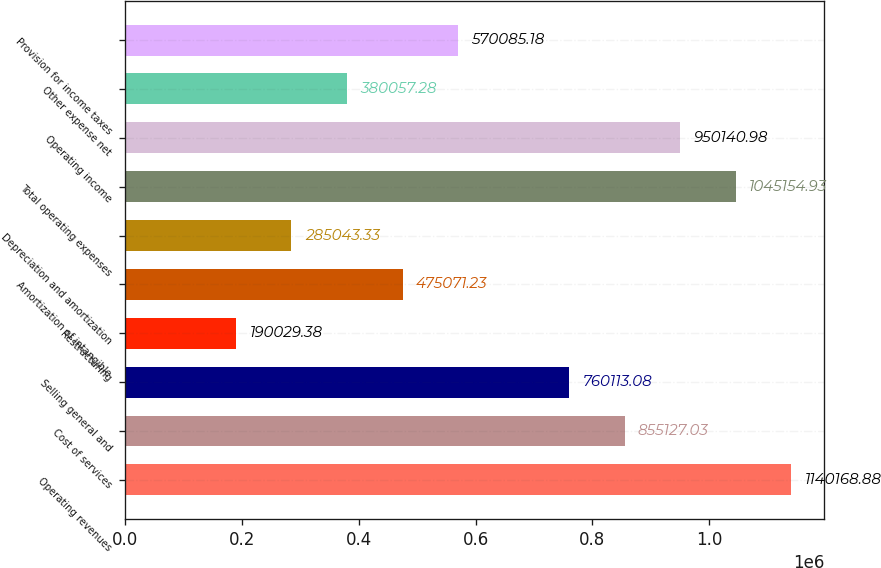Convert chart. <chart><loc_0><loc_0><loc_500><loc_500><bar_chart><fcel>Operating revenues<fcel>Cost of services<fcel>Selling general and<fcel>Restructuring<fcel>Amortization of intangible<fcel>Depreciation and amortization<fcel>Total operating expenses<fcel>Operating income<fcel>Other expense net<fcel>Provision for income taxes<nl><fcel>1.14017e+06<fcel>855127<fcel>760113<fcel>190029<fcel>475071<fcel>285043<fcel>1.04515e+06<fcel>950141<fcel>380057<fcel>570085<nl></chart> 